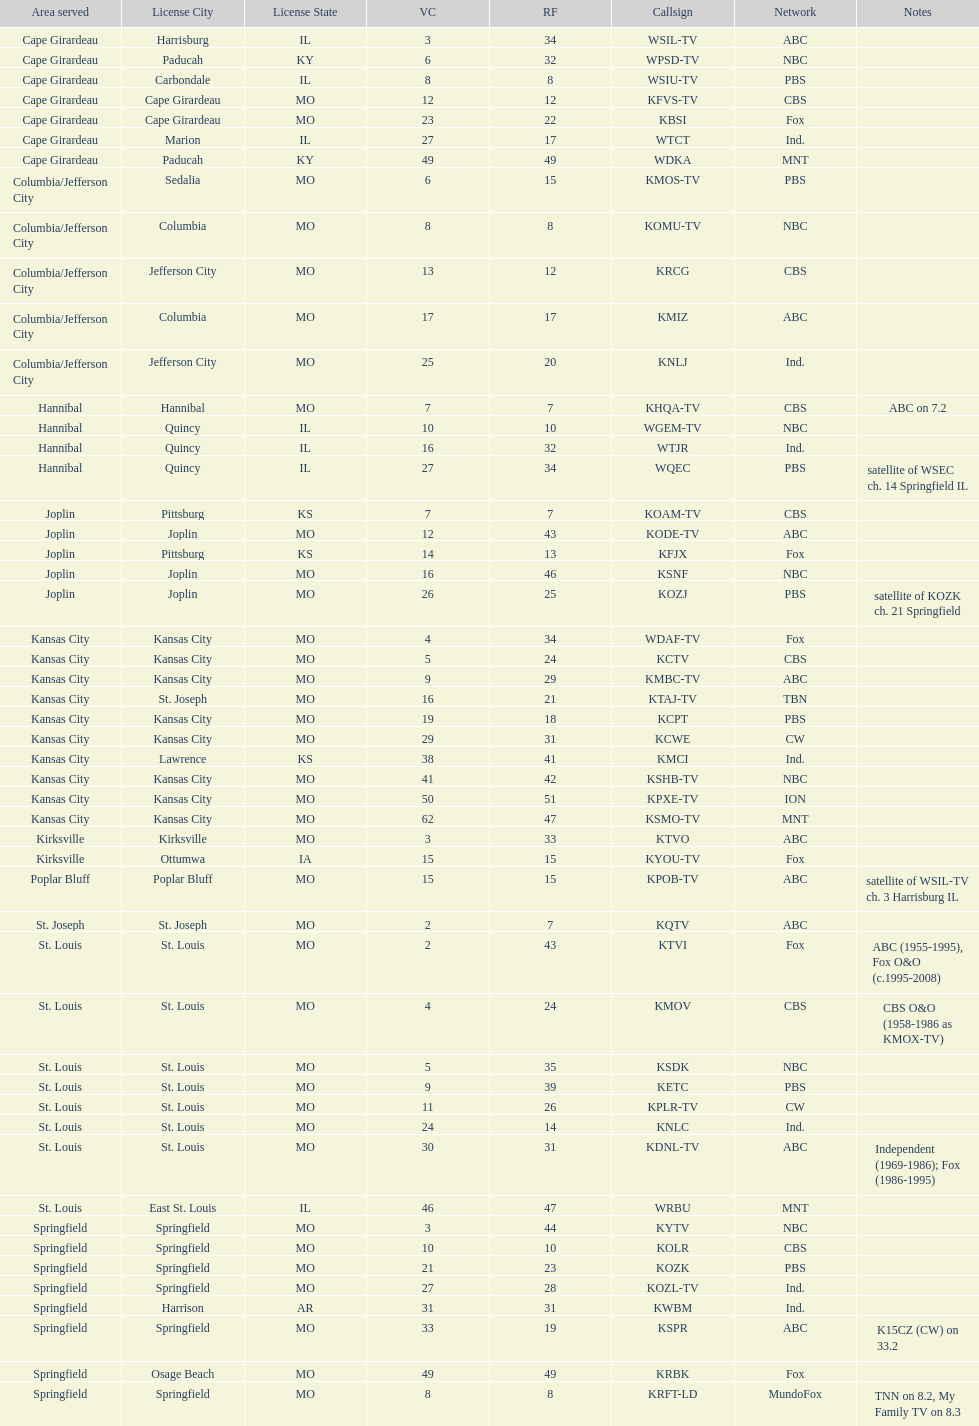What is the total number of stations serving the the cape girardeau area? 7. 